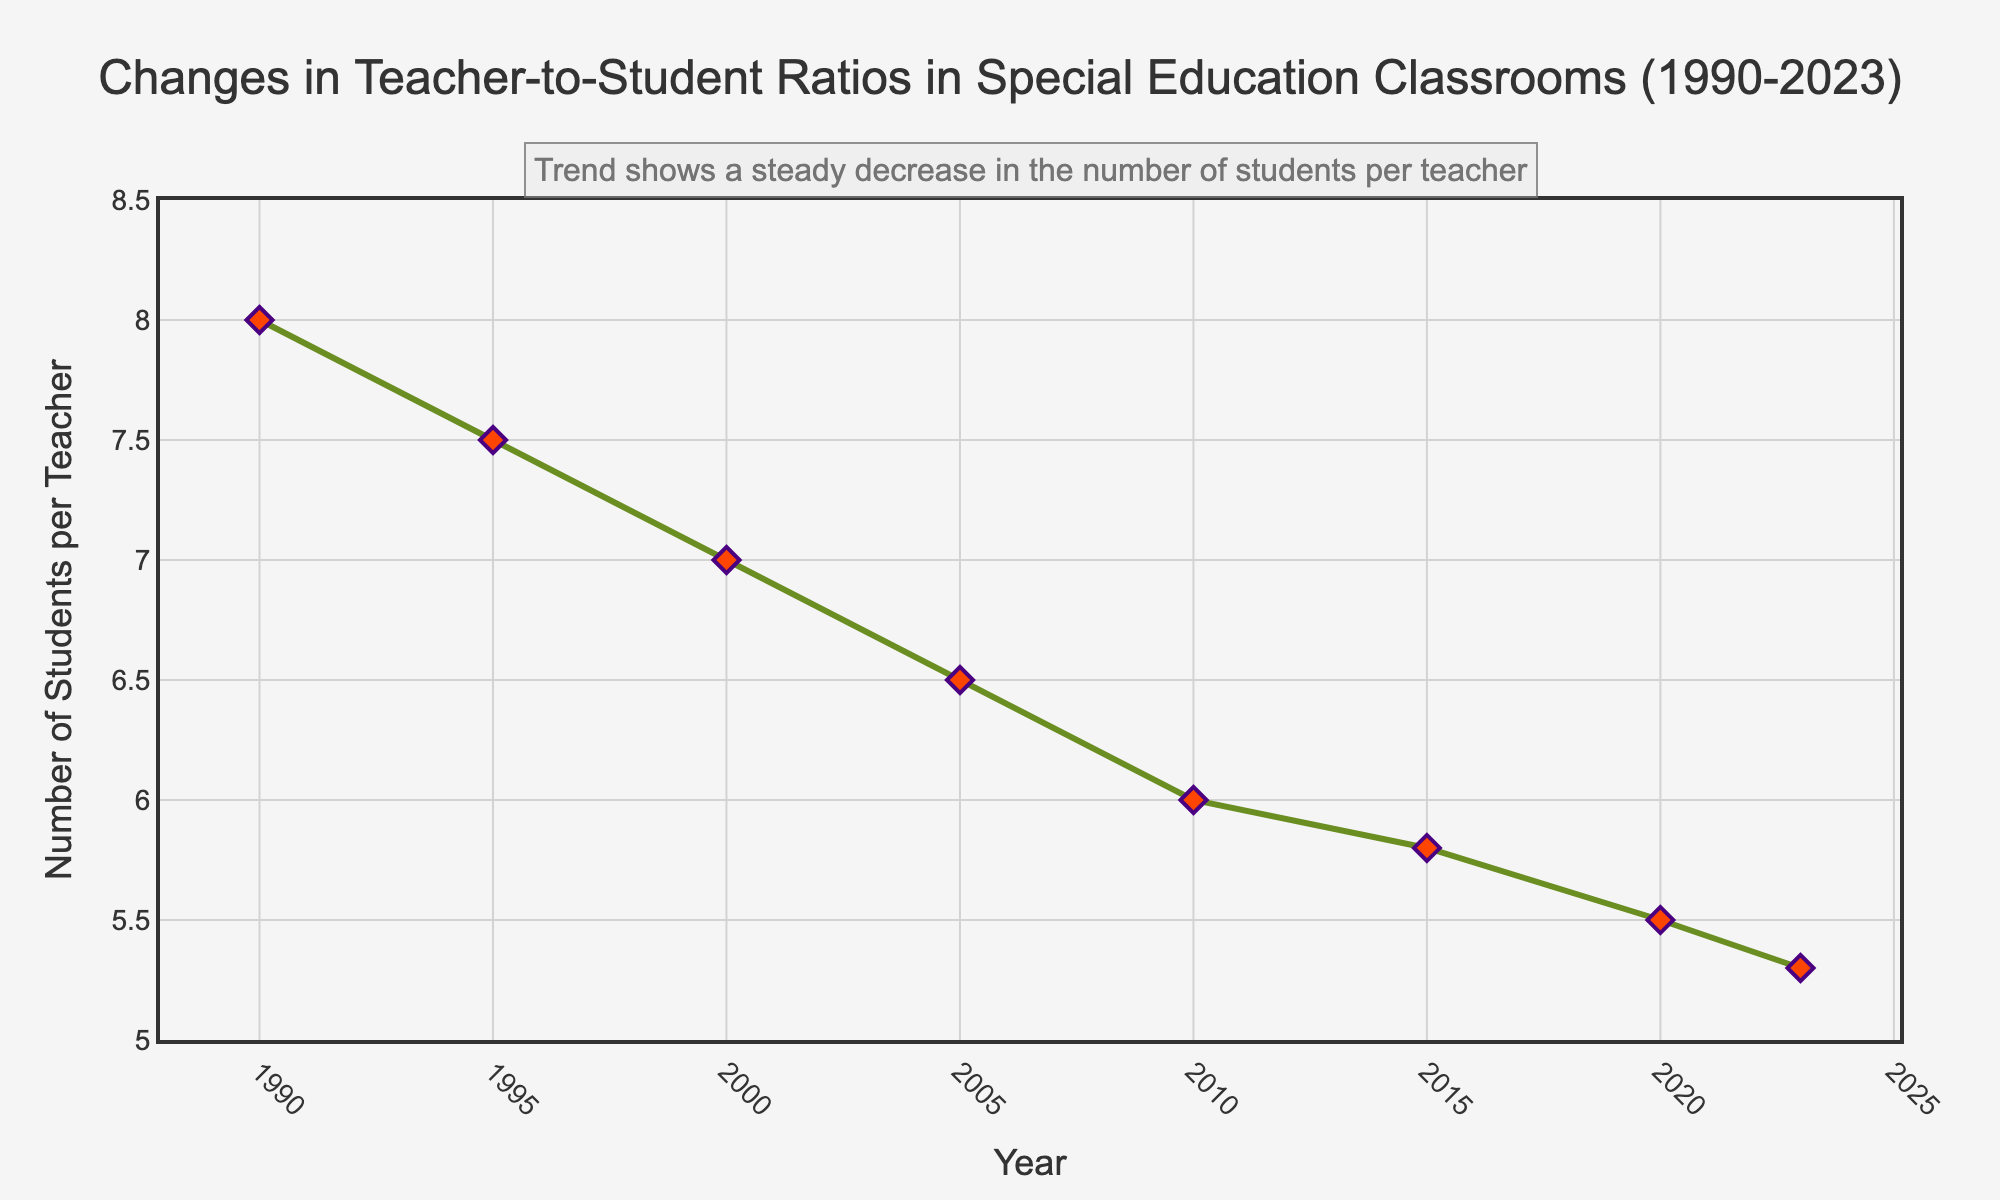what is the teacher-to-student ratio in the year 2005? Look at the data point corresponding to the year 2005, which shows '1:6.5'. This means the teacher-to-student ratio in 2005 was 1 teacher for every 6.5 students.
Answer: 1:6.5 how has the teacher-to-student ratio changed from 1990 to 2023? Compare the ratios from 1990 ('1:8') and 2023 ('1:5.3'). This shows a decrease in the number of students per teacher. Subtract 5.3 from 8 to find the change, which is 2.7.
Answer: Decreased by 2.7 compare the teacher-to-student ratio in 2000 and 2020 Check the teacher-to-student ratios for the years 2000 ('1:7') and 2020 ('1:5.5'). The ratio in 2020 is lower than in 2000.
Answer: 2000 ratio is higher what is the overall trend in the teacher-to-student ratio from 1990 to 2023? Observing the plot from left to right, from 1990 to 2023, indicates that the teacher-to-student ratio steadily decreases each year.
Answer: Steady decrease between which consecutive years did the teacher-to-student ratio decrease the most? Calculate the differences between consecutive years: 1990-1995 (0.5), 1995-2000 (0.5), 2000-2005 (0.5), 2005-2010 (0.5), 2010-2015 (0.2), 2015-2020 (0.3), 2020-2023 (0.2). The maximum decrease is between 1990-1995.
Answer: 1990 and 1995 what's the average teacher-to-student ratio over the years presented? First, convert ratios to values and sum them: 8 + 7.5 + 7 + 6.5 + 6 + 5.8 + 5.5 + 5.3 = 51.6. Then, divide by the number of years (8): 51.6 / 8 = 6.45.
Answer: 6.45 which year had a teacher-to-student ratio of 1:7? By locating the ratio '1:7' in the provided data, it corresponds to the year 2000.
Answer: 2000 how does the teacher-to-student ratio in 1995 compare to that in 2015? The ratio in 1995 was '1:7.5' and in 2015 it was '1:5.8'. Since 7.5 is greater than 5.8, the ratio decreased over this period.
Answer: 1995 ratio is higher what visual elements indicate a decrease in the teacher-to-student ratio over time? The downward slope of the green line, the decreasing y-values marked by red diamonds over time, and the annotation text all indicate a decreasing trend in the teacher-to-student ratio.
Answer: Downward slope and decreasing markers if the trend continues, predict the teacher-to-student ratio for 2025 Observing the trend, the ratio decreases by an average of approximately 0.05 per year from the 2020-2023 data (5.5 to 5.3 over 3 years). Applying this average gives an estimated ratio of 1:5.1 or slightly lower.
Answer: Approximately 1:5.1 